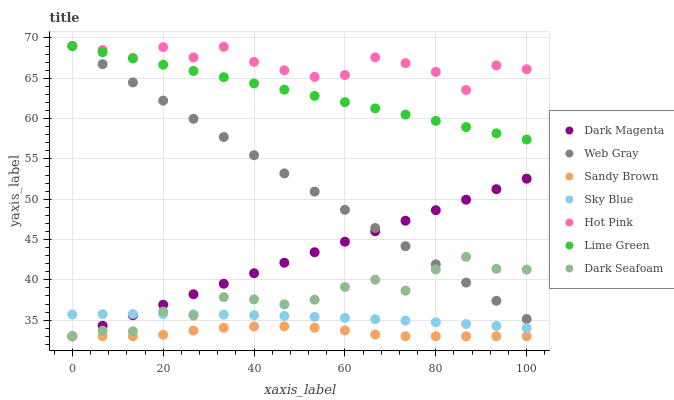Does Sandy Brown have the minimum area under the curve?
Answer yes or no. Yes. Does Hot Pink have the maximum area under the curve?
Answer yes or no. Yes. Does Dark Magenta have the minimum area under the curve?
Answer yes or no. No. Does Dark Magenta have the maximum area under the curve?
Answer yes or no. No. Is Dark Magenta the smoothest?
Answer yes or no. Yes. Is Hot Pink the roughest?
Answer yes or no. Yes. Is Lime Green the smoothest?
Answer yes or no. No. Is Lime Green the roughest?
Answer yes or no. No. Does Dark Magenta have the lowest value?
Answer yes or no. Yes. Does Lime Green have the lowest value?
Answer yes or no. No. Does Hot Pink have the highest value?
Answer yes or no. Yes. Does Dark Magenta have the highest value?
Answer yes or no. No. Is Dark Seafoam less than Hot Pink?
Answer yes or no. Yes. Is Hot Pink greater than Dark Seafoam?
Answer yes or no. Yes. Does Sandy Brown intersect Dark Seafoam?
Answer yes or no. Yes. Is Sandy Brown less than Dark Seafoam?
Answer yes or no. No. Is Sandy Brown greater than Dark Seafoam?
Answer yes or no. No. Does Dark Seafoam intersect Hot Pink?
Answer yes or no. No. 